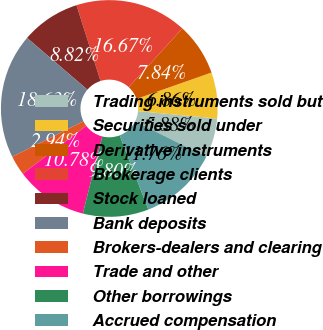Convert chart. <chart><loc_0><loc_0><loc_500><loc_500><pie_chart><fcel>Trading instruments sold but<fcel>Securities sold under<fcel>Derivative instruments<fcel>Brokerage clients<fcel>Stock loaned<fcel>Bank deposits<fcel>Brokers-dealers and clearing<fcel>Trade and other<fcel>Other borrowings<fcel>Accrued compensation<nl><fcel>5.88%<fcel>6.86%<fcel>7.84%<fcel>16.67%<fcel>8.82%<fcel>18.63%<fcel>2.94%<fcel>10.78%<fcel>9.8%<fcel>11.76%<nl></chart> 